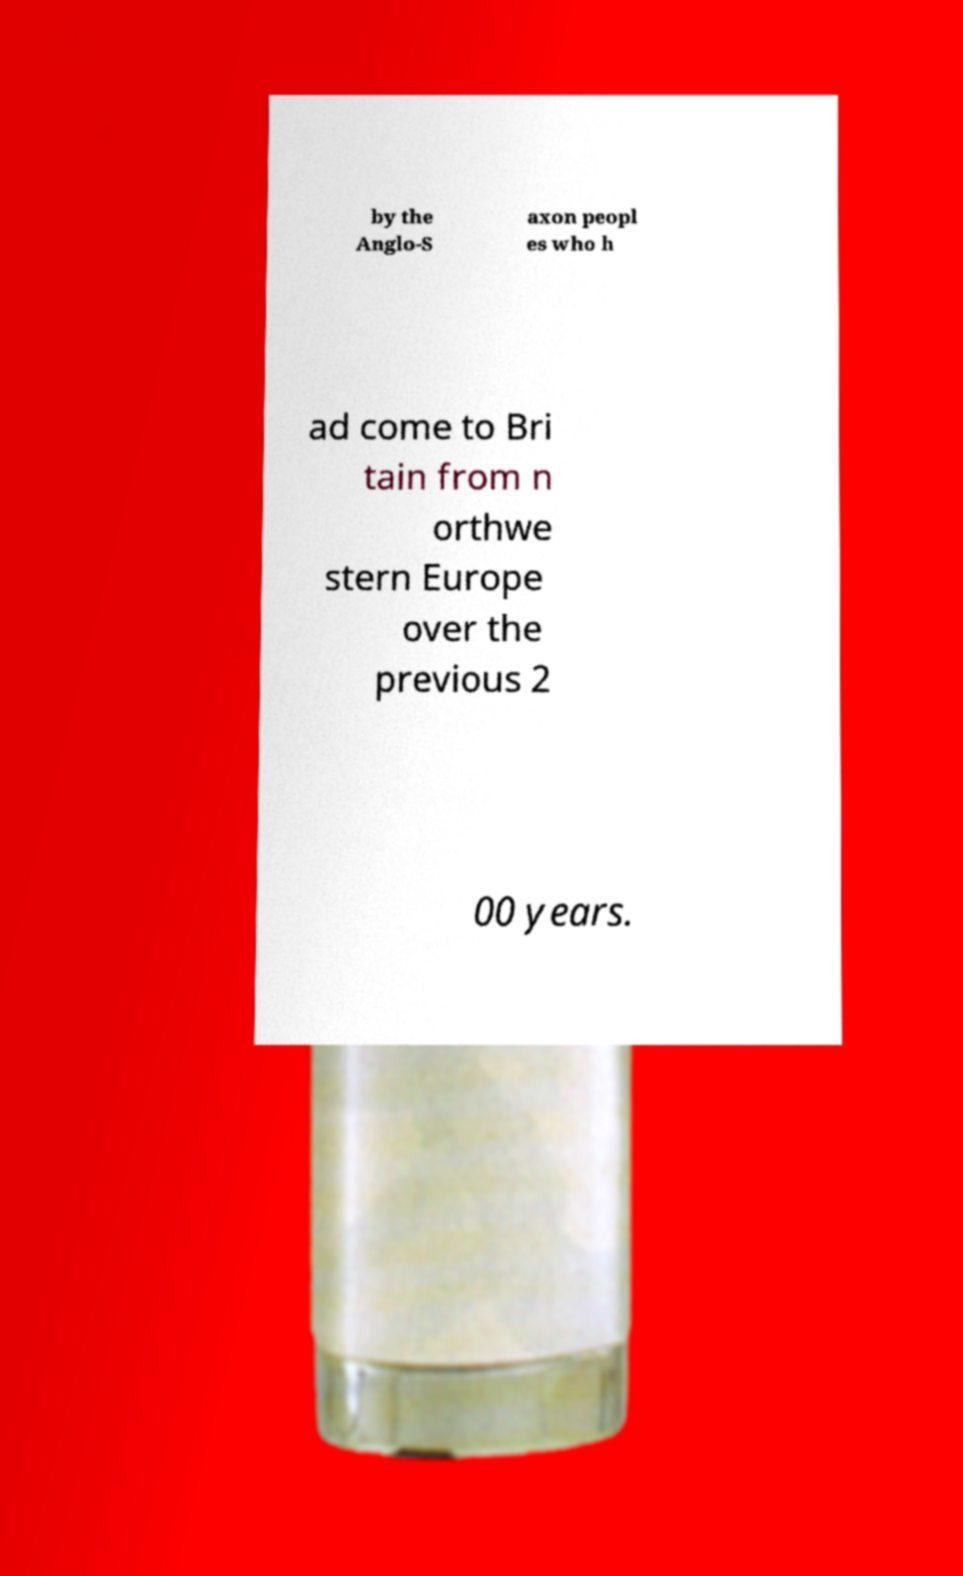There's text embedded in this image that I need extracted. Can you transcribe it verbatim? by the Anglo-S axon peopl es who h ad come to Bri tain from n orthwe stern Europe over the previous 2 00 years. 